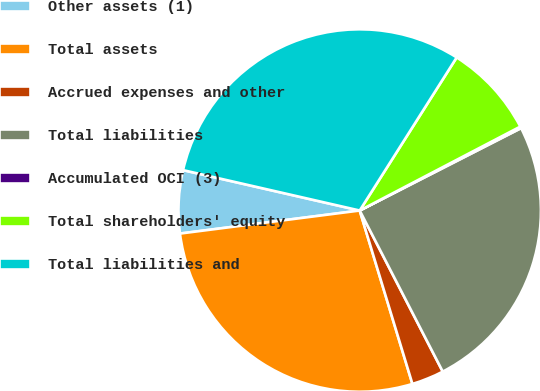Convert chart to OTSL. <chart><loc_0><loc_0><loc_500><loc_500><pie_chart><fcel>Other assets (1)<fcel>Total assets<fcel>Accrued expenses and other<fcel>Total liabilities<fcel>Accumulated OCI (3)<fcel>Total shareholders' equity<fcel>Total liabilities and<nl><fcel>5.61%<fcel>27.67%<fcel>2.88%<fcel>24.94%<fcel>0.15%<fcel>8.35%<fcel>30.41%<nl></chart> 